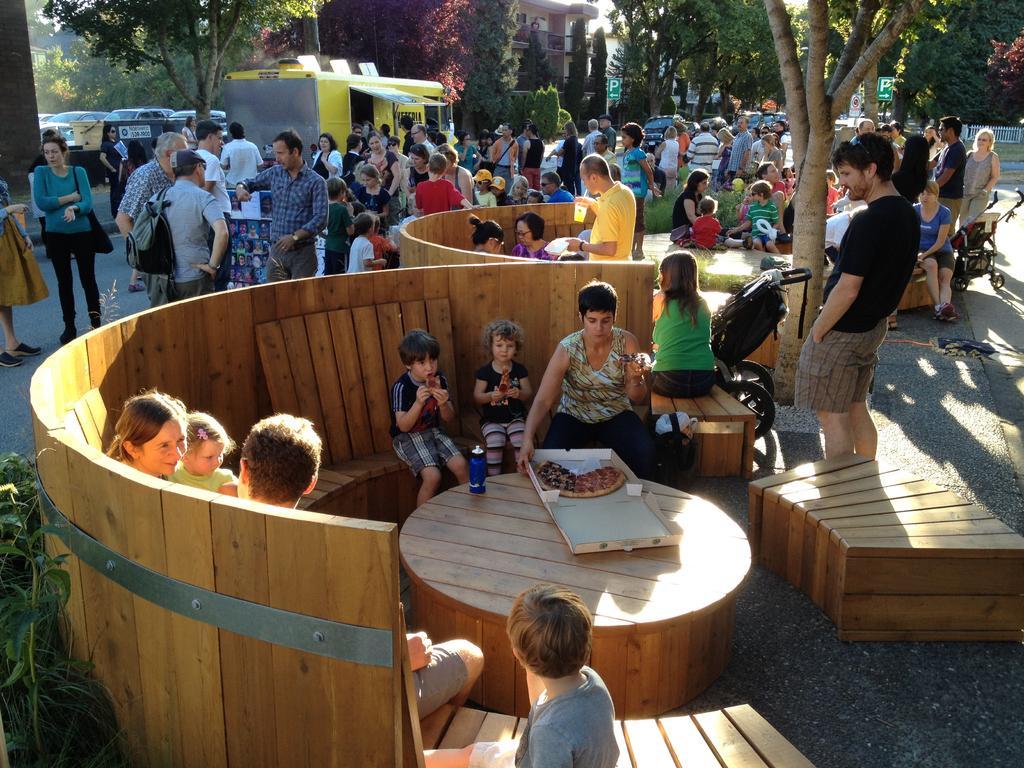Please provide a concise description of this image. This is a picture taken in the outdoors. It is sunny. There are group of people siting on a bench in front of the people there is a table on the table there is a box with food. Behind the people there are group of people standing on a path. Background of the people is a stall, trees and building. 